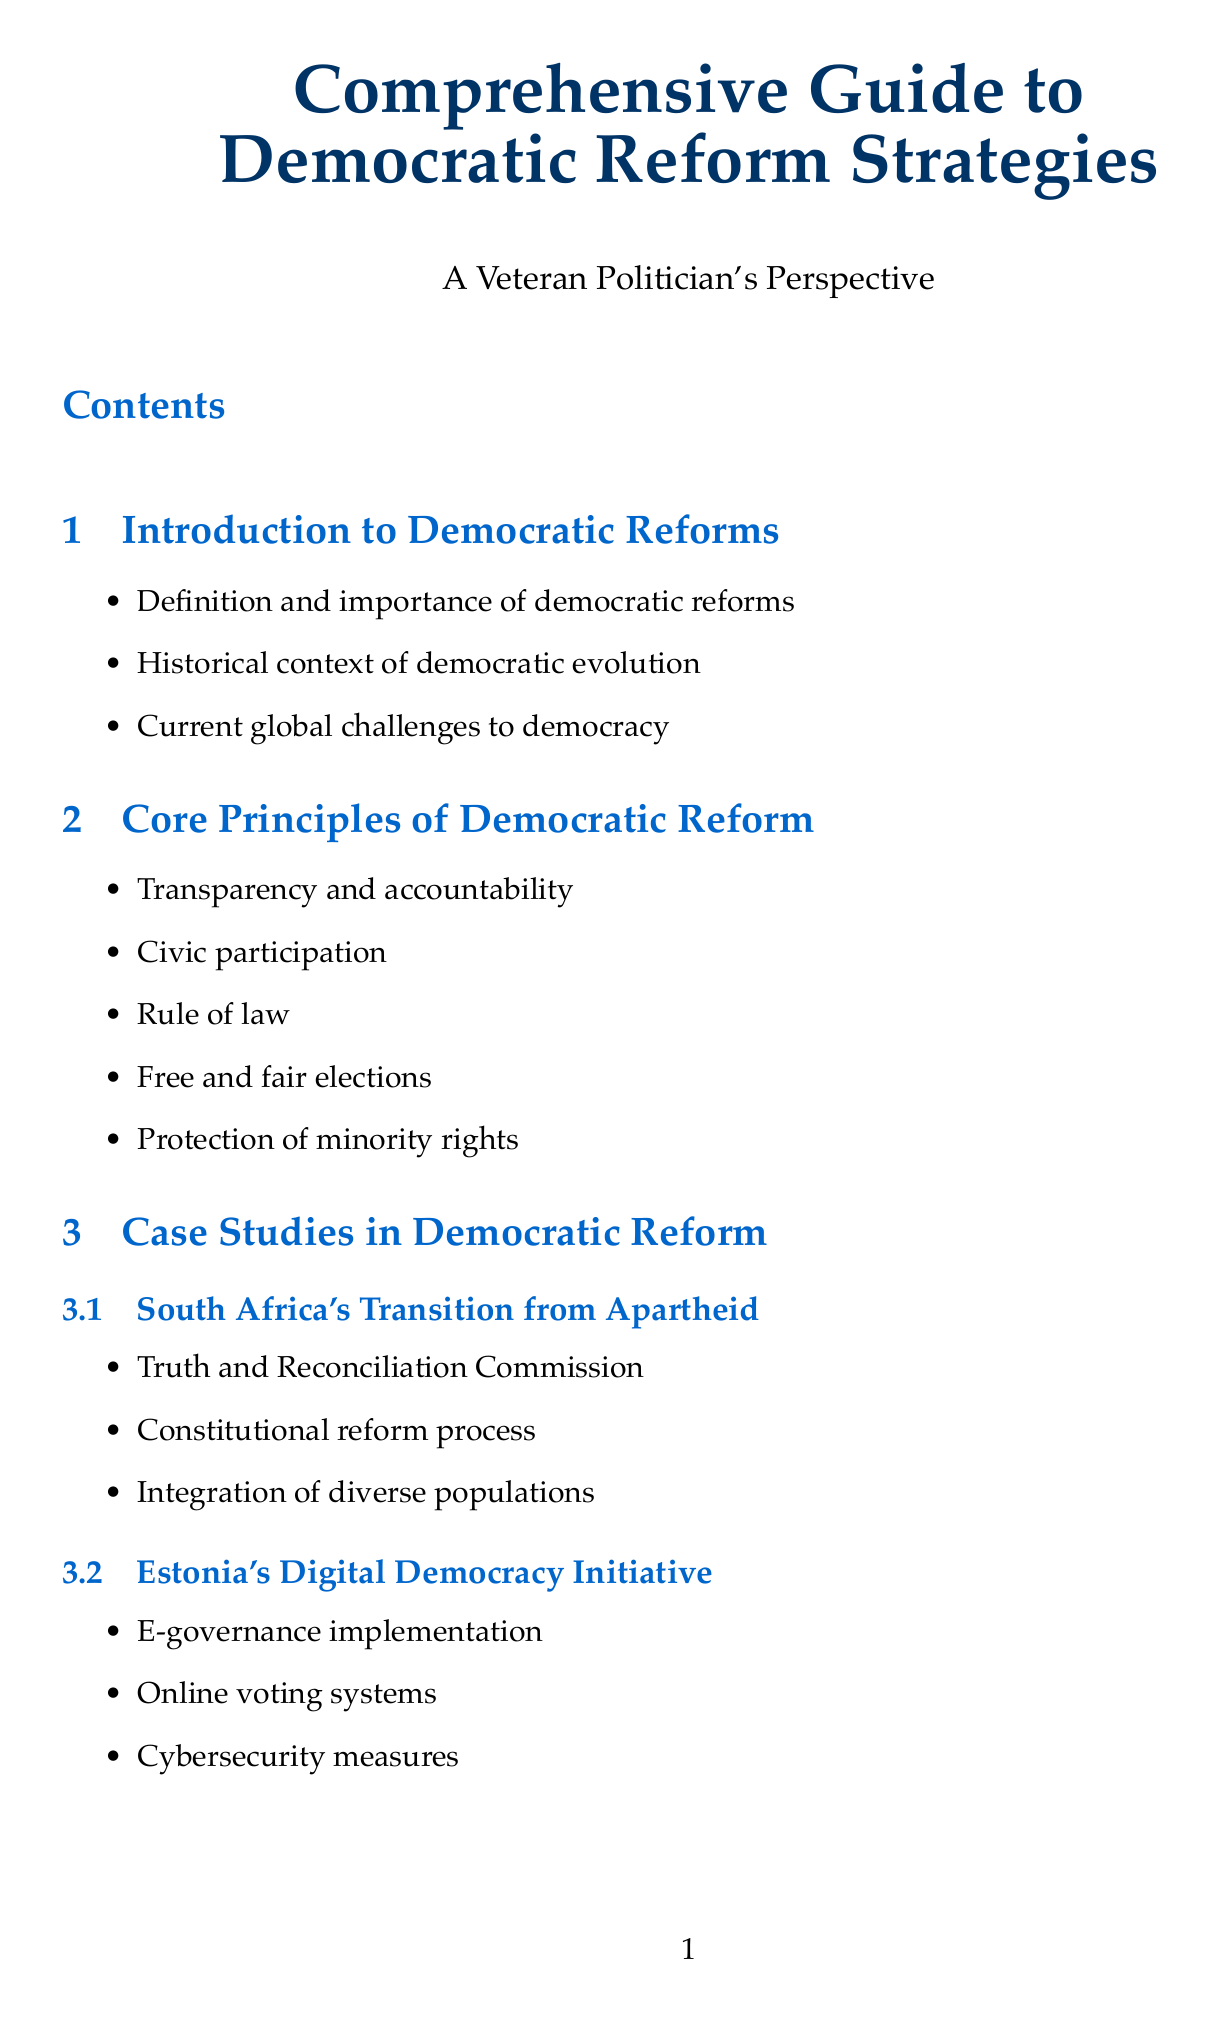What is the title of the document? The title of the document is stated at the beginning.
Answer: Comprehensive Guide to Democratic Reform Strategies How many case studies are included in the document? The document lists three specific case studies under the relevant section.
Answer: 3 What framework does the Venice Commission provide? The Venice Commission is mentioned as a framework for democratic institutions in the relevant section.
Answer: Framework for democratic institutions Which country is associated with a digital democracy initiative? The document references a specific initiative tied to Estonia in the case studies.
Answer: Estonia What is one strategy for effective reform mentioned? The document lists several strategies under the strategies section.
Answer: Building coalitions and consensus What is a key principle of democratic reform? Core principles are explicitly outlined in the document.
Answer: Transparency and accountability Who is encouraged to be nurtured in the mentorship section? The document specifically mentions a group that should be identified and nurtured.
Answer: Emerging leaders How many organizations are listed in the directory of democratic support organizations? The document includes four organizations in the directory.
Answer: 4 